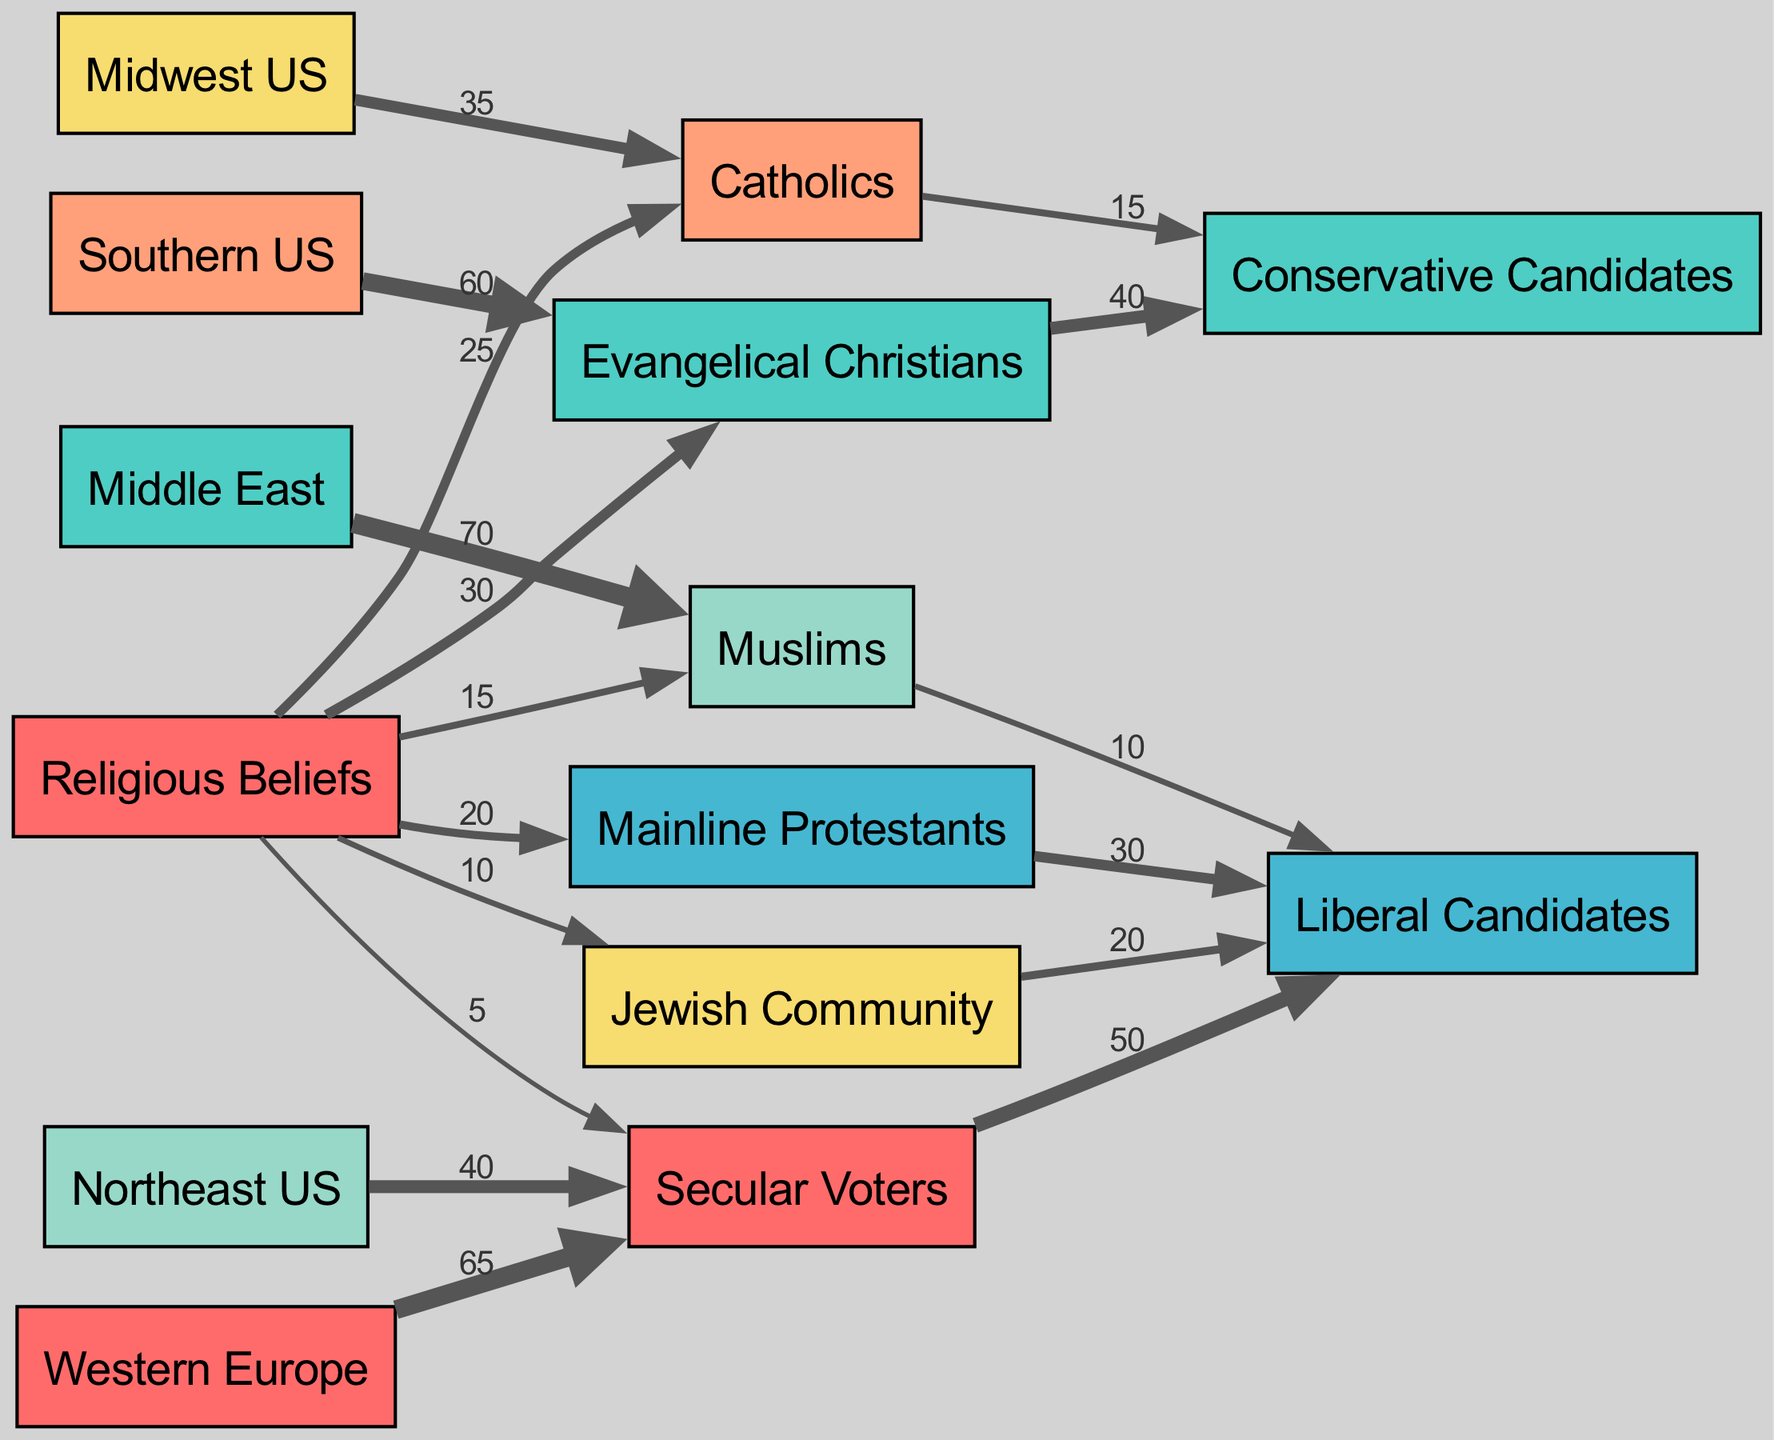What is the total number of nodes in the diagram? The diagram contains 14 nodes, which include various religious groups and regions as well as categories of voters and candidates.
Answer: 14 Which religious group has the highest value linked to Conservative Candidates? Evangelical Christians have the highest value linked to Conservative Candidates, with a value of 40.
Answer: 40 What is the value of the connection between Catholics and Liberal Candidates? The connection between Catholics and Liberal Candidates has a value of 15.
Answer: 15 In which region do the majority of Evangelical Christians reside? The Southern US has the majority of Evangelical Christians, indicated by a value of 60 linked to this region.
Answer: Southern US What is the total value of connections leading from Secular Voters to Liberal Candidates? The value of connections from Secular Voters to Liberal Candidates totals to 50, which is the only link connecting them.
Answer: 50 Which religious group has the lowest value and what is it? Secular Voters have the lowest value at 5, indicated by the link to Religious Beliefs.
Answer: 5 How many links are connected to the Jewish Community? There are 1 link connected to the Jewish Community leading to Liberal Candidates with a value of 20.
Answer: 1 What can be inferred about the voting behavior of Muslims in the Middle East? Muslims in the Middle East predominantly support Liberal Candidates, as shown by the link with a value of 10 leading to Liberal Candidates.
Answer: 10 Which religious belief contributes the most to Liberal Candidates? Secular Voters contribute the most to Liberal Candidates with the highest value of 50.
Answer: 50 